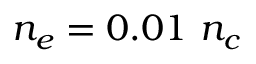Convert formula to latex. <formula><loc_0><loc_0><loc_500><loc_500>n _ { e } = 0 . 0 1 n _ { c }</formula> 